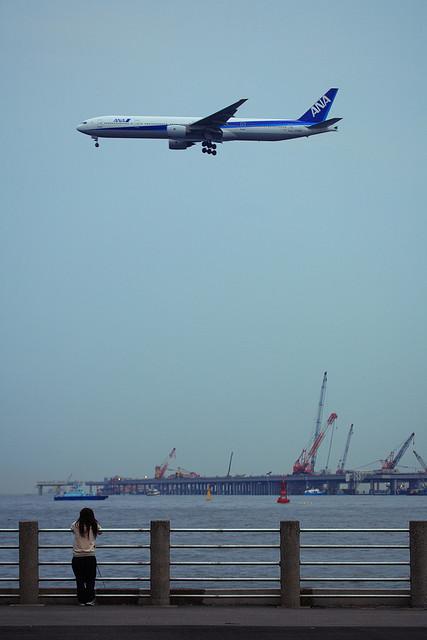Does the person have long hair?
Short answer required. Yes. How many wheels are in the air?
Short answer required. 4. Which airline does the plane belong to?
Concise answer only. Ana. 